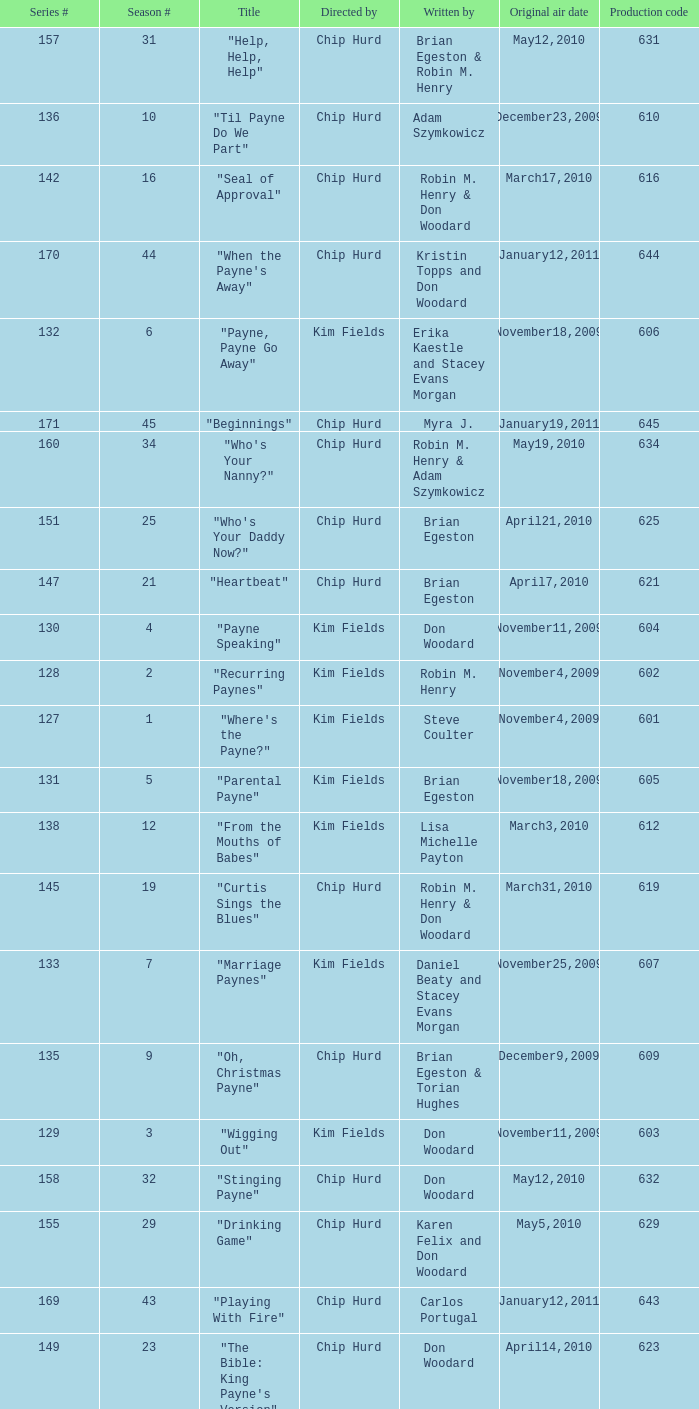What is the title of the episode with the production code 624? "Matured Investment". Could you parse the entire table as a dict? {'header': ['Series #', 'Season #', 'Title', 'Directed by', 'Written by', 'Original air date', 'Production code'], 'rows': [['157', '31', '"Help, Help, Help"', 'Chip Hurd', 'Brian Egeston & Robin M. Henry', 'May12,2010', '631'], ['136', '10', '"Til Payne Do We Part"', 'Chip Hurd', 'Adam Szymkowicz', 'December23,2009', '610'], ['142', '16', '"Seal of Approval"', 'Chip Hurd', 'Robin M. Henry & Don Woodard', 'March17,2010', '616'], ['170', '44', '"When the Payne\'s Away"', 'Chip Hurd', 'Kristin Topps and Don Woodard', 'January12,2011', '644'], ['132', '6', '"Payne, Payne Go Away"', 'Kim Fields', 'Erika Kaestle and Stacey Evans Morgan', 'November18,2009', '606'], ['171', '45', '"Beginnings"', 'Chip Hurd', 'Myra J.', 'January19,2011', '645'], ['160', '34', '"Who\'s Your Nanny?"', 'Chip Hurd', 'Robin M. Henry & Adam Szymkowicz', 'May19,2010', '634'], ['151', '25', '"Who\'s Your Daddy Now?"', 'Chip Hurd', 'Brian Egeston', 'April21,2010', '625'], ['147', '21', '"Heartbeat"', 'Chip Hurd', 'Brian Egeston', 'April7,2010', '621'], ['130', '4', '"Payne Speaking"', 'Kim Fields', 'Don Woodard', 'November11,2009', '604'], ['128', '2', '"Recurring Paynes"', 'Kim Fields', 'Robin M. Henry', 'November4,2009', '602'], ['127', '1', '"Where\'s the Payne?"', 'Kim Fields', 'Steve Coulter', 'November4,2009', '601'], ['131', '5', '"Parental Payne"', 'Kim Fields', 'Brian Egeston', 'November18,2009', '605'], ['138', '12', '"From the Mouths of Babes"', 'Kim Fields', 'Lisa Michelle Payton', 'March3,2010', '612'], ['145', '19', '"Curtis Sings the Blues"', 'Chip Hurd', 'Robin M. Henry & Don Woodard', 'March31,2010', '619'], ['133', '7', '"Marriage Paynes"', 'Kim Fields', 'Daniel Beaty and Stacey Evans Morgan', 'November25,2009', '607'], ['135', '9', '"Oh, Christmas Payne"', 'Chip Hurd', 'Brian Egeston & Torian Hughes', 'December9,2009', '609'], ['129', '3', '"Wigging Out"', 'Kim Fields', 'Don Woodard', 'November11,2009', '603'], ['158', '32', '"Stinging Payne"', 'Chip Hurd', 'Don Woodard', 'May12,2010', '632'], ['155', '29', '"Drinking Game"', 'Chip Hurd', 'Karen Felix and Don Woodard', 'May5,2010', '629'], ['169', '43', '"Playing With Fire"', 'Chip Hurd', 'Carlos Portugal', 'January12,2011', '643'], ['149', '23', '"The Bible: King Payne\'s Version"', 'Chip Hurd', 'Don Woodard', 'April14,2010', '623'], ['153', '27', '"Date Night x 3"', 'Chip Hurd', 'Adam Szymkowicz', 'April28,2010', '627'], ['139', '13', '"Blackout X 3"', 'Kim Fields', 'Adam Szymkowicz', 'March10,2010', '613'], ['165', '39', '"Rehabilitation"', 'Chip Hurd', 'Adam Szymkowicz', 'June9,2010', '639'], ['144', '18', '"How Do You Like Your Roast?"', 'Chip Hurd', 'Robin M. Henry & Steve Coulter', 'March25,2010', '618'], ['164', '38', '"Thug Life"', 'Chip Hurd', 'Torian Hughes', 'June2,2010', '638'], ['163', '37', '"Rest for the Weary"', 'Chip Hurd', 'Brian Egeston', 'June2,2010', '637'], ['154', '28', '"Watch the Son Shine"', 'Chip Hurd', 'Brian Egeston & Adam Szymkowicz', 'April28,2010', '628'], ['146', '20', '"Firestorm"', 'Chip Hurd', 'Torian Hughes', 'March31,2010', '620'], ['162', '36', '"My Fair Curtis"', 'Chip Hurd', 'Don Woodard', 'May26,2010', '636'], ['159', '33', '"Worth Fighting For"', 'Chip Hurd', 'Torian Hughes', 'May19,2010', '633'], ['137', '11', '"Payneful Reunion"', 'Chip Hurd', 'Torian Hughes', 'March3,2010', '611'], ['143', '17', '"Payneful Pie"', 'Chip Hurd', 'Kellie Zimmerman-Green', 'March25,2010', '617'], ['166', '40', '"A Payne In Need Is A Pain Indeed"', 'Chip Hurd', 'Don Woodard', 'June9,2010', '640'], ['167', '41', '"House Guest"', 'Chip Hurd', 'David A. Arnold', 'January5,2011', '641'], ['161', '35', '"The Chef"', 'Chip Hurd', 'Anthony C. Hill', 'May26,2010', '635'], ['150', '24', '"Matured Investment"', 'Chip Hurd', 'Torian Hughes', 'April14,2010', '624'], ['134', '8', '"Ms. Curtis"', 'Kim Fields', 'Spencer Gilbert', 'December2,2009', '608'], ['156', '30', '"Who\'s On Top?"', 'Chip Hurd', 'Robin M. Henry & Torian Hughes', 'May5,2010', '630'], ['141', '15', '"Something\'s Brewing"', 'Chip Hurd', 'Don Woodard & Steve Coulter', 'March17,2010', '615'], ['168', '42', '"Payne Showers"', 'Chip Hurd', 'Omega Mariaunnie Stewart and Torian Hughes', 'January5,2011', '642'], ['152', '26', '"Feet of Clay"', 'Chip Hurd', 'Don Woodard', 'April21,2010', '626'], ['140', '14', '"Lady Sings the Blues"', 'Chip Hurd', 'Steve Coulter & Don Woodard', 'March10,2010', '614'], ['148', '22', '"Through the Fire"', 'Chip Hurd', 'Robin M. Henry', 'April7,2010', '622']]} 